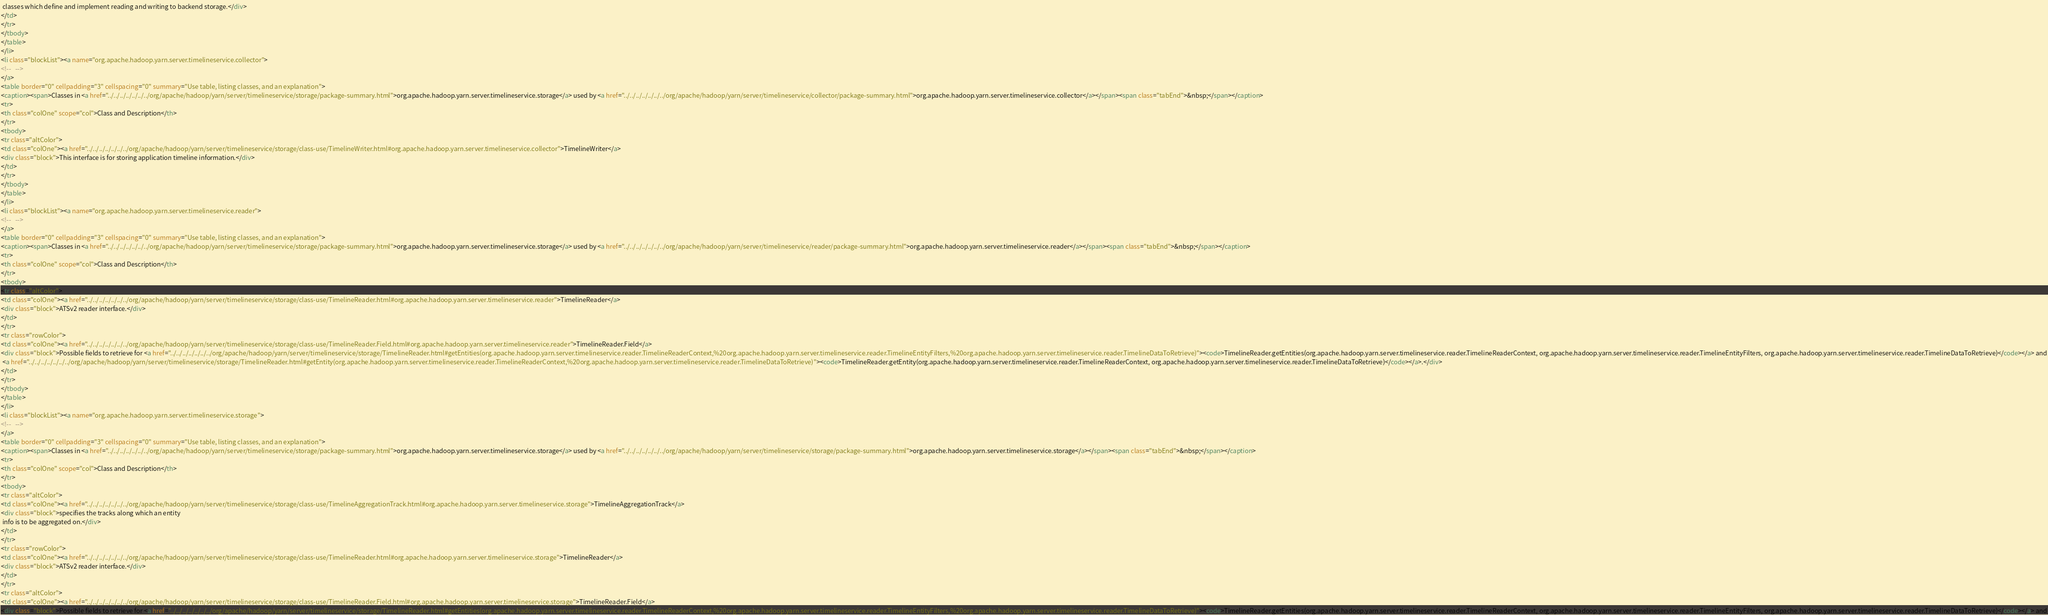Convert code to text. <code><loc_0><loc_0><loc_500><loc_500><_HTML_> classes which define and implement reading and writing to backend storage.</div>
</td>
</tr>
</tbody>
</table>
</li>
<li class="blockList"><a name="org.apache.hadoop.yarn.server.timelineservice.collector">
<!--   -->
</a>
<table border="0" cellpadding="3" cellspacing="0" summary="Use table, listing classes, and an explanation">
<caption><span>Classes in <a href="../../../../../../../org/apache/hadoop/yarn/server/timelineservice/storage/package-summary.html">org.apache.hadoop.yarn.server.timelineservice.storage</a> used by <a href="../../../../../../../org/apache/hadoop/yarn/server/timelineservice/collector/package-summary.html">org.apache.hadoop.yarn.server.timelineservice.collector</a></span><span class="tabEnd">&nbsp;</span></caption>
<tr>
<th class="colOne" scope="col">Class and Description</th>
</tr>
<tbody>
<tr class="altColor">
<td class="colOne"><a href="../../../../../../../org/apache/hadoop/yarn/server/timelineservice/storage/class-use/TimelineWriter.html#org.apache.hadoop.yarn.server.timelineservice.collector">TimelineWriter</a>
<div class="block">This interface is for storing application timeline information.</div>
</td>
</tr>
</tbody>
</table>
</li>
<li class="blockList"><a name="org.apache.hadoop.yarn.server.timelineservice.reader">
<!--   -->
</a>
<table border="0" cellpadding="3" cellspacing="0" summary="Use table, listing classes, and an explanation">
<caption><span>Classes in <a href="../../../../../../../org/apache/hadoop/yarn/server/timelineservice/storage/package-summary.html">org.apache.hadoop.yarn.server.timelineservice.storage</a> used by <a href="../../../../../../../org/apache/hadoop/yarn/server/timelineservice/reader/package-summary.html">org.apache.hadoop.yarn.server.timelineservice.reader</a></span><span class="tabEnd">&nbsp;</span></caption>
<tr>
<th class="colOne" scope="col">Class and Description</th>
</tr>
<tbody>
<tr class="altColor">
<td class="colOne"><a href="../../../../../../../org/apache/hadoop/yarn/server/timelineservice/storage/class-use/TimelineReader.html#org.apache.hadoop.yarn.server.timelineservice.reader">TimelineReader</a>
<div class="block">ATSv2 reader interface.</div>
</td>
</tr>
<tr class="rowColor">
<td class="colOne"><a href="../../../../../../../org/apache/hadoop/yarn/server/timelineservice/storage/class-use/TimelineReader.Field.html#org.apache.hadoop.yarn.server.timelineservice.reader">TimelineReader.Field</a>
<div class="block">Possible fields to retrieve for <a href="../../../../../../../org/apache/hadoop/yarn/server/timelineservice/storage/TimelineReader.html#getEntities(org.apache.hadoop.yarn.server.timelineservice.reader.TimelineReaderContext,%20org.apache.hadoop.yarn.server.timelineservice.reader.TimelineEntityFilters,%20org.apache.hadoop.yarn.server.timelineservice.reader.TimelineDataToRetrieve)"><code>TimelineReader.getEntities(org.apache.hadoop.yarn.server.timelineservice.reader.TimelineReaderContext, org.apache.hadoop.yarn.server.timelineservice.reader.TimelineEntityFilters, org.apache.hadoop.yarn.server.timelineservice.reader.TimelineDataToRetrieve)</code></a> and
 <a href="../../../../../../../org/apache/hadoop/yarn/server/timelineservice/storage/TimelineReader.html#getEntity(org.apache.hadoop.yarn.server.timelineservice.reader.TimelineReaderContext,%20org.apache.hadoop.yarn.server.timelineservice.reader.TimelineDataToRetrieve)"><code>TimelineReader.getEntity(org.apache.hadoop.yarn.server.timelineservice.reader.TimelineReaderContext, org.apache.hadoop.yarn.server.timelineservice.reader.TimelineDataToRetrieve)</code></a>.</div>
</td>
</tr>
</tbody>
</table>
</li>
<li class="blockList"><a name="org.apache.hadoop.yarn.server.timelineservice.storage">
<!--   -->
</a>
<table border="0" cellpadding="3" cellspacing="0" summary="Use table, listing classes, and an explanation">
<caption><span>Classes in <a href="../../../../../../../org/apache/hadoop/yarn/server/timelineservice/storage/package-summary.html">org.apache.hadoop.yarn.server.timelineservice.storage</a> used by <a href="../../../../../../../org/apache/hadoop/yarn/server/timelineservice/storage/package-summary.html">org.apache.hadoop.yarn.server.timelineservice.storage</a></span><span class="tabEnd">&nbsp;</span></caption>
<tr>
<th class="colOne" scope="col">Class and Description</th>
</tr>
<tbody>
<tr class="altColor">
<td class="colOne"><a href="../../../../../../../org/apache/hadoop/yarn/server/timelineservice/storage/class-use/TimelineAggregationTrack.html#org.apache.hadoop.yarn.server.timelineservice.storage">TimelineAggregationTrack</a>
<div class="block">specifies the tracks along which an entity
 info is to be aggregated on.</div>
</td>
</tr>
<tr class="rowColor">
<td class="colOne"><a href="../../../../../../../org/apache/hadoop/yarn/server/timelineservice/storage/class-use/TimelineReader.html#org.apache.hadoop.yarn.server.timelineservice.storage">TimelineReader</a>
<div class="block">ATSv2 reader interface.</div>
</td>
</tr>
<tr class="altColor">
<td class="colOne"><a href="../../../../../../../org/apache/hadoop/yarn/server/timelineservice/storage/class-use/TimelineReader.Field.html#org.apache.hadoop.yarn.server.timelineservice.storage">TimelineReader.Field</a>
<div class="block">Possible fields to retrieve for <a href="../../../../../../../org/apache/hadoop/yarn/server/timelineservice/storage/TimelineReader.html#getEntities(org.apache.hadoop.yarn.server.timelineservice.reader.TimelineReaderContext,%20org.apache.hadoop.yarn.server.timelineservice.reader.TimelineEntityFilters,%20org.apache.hadoop.yarn.server.timelineservice.reader.TimelineDataToRetrieve)"><code>TimelineReader.getEntities(org.apache.hadoop.yarn.server.timelineservice.reader.TimelineReaderContext, org.apache.hadoop.yarn.server.timelineservice.reader.TimelineEntityFilters, org.apache.hadoop.yarn.server.timelineservice.reader.TimelineDataToRetrieve)</code></a> and</code> 